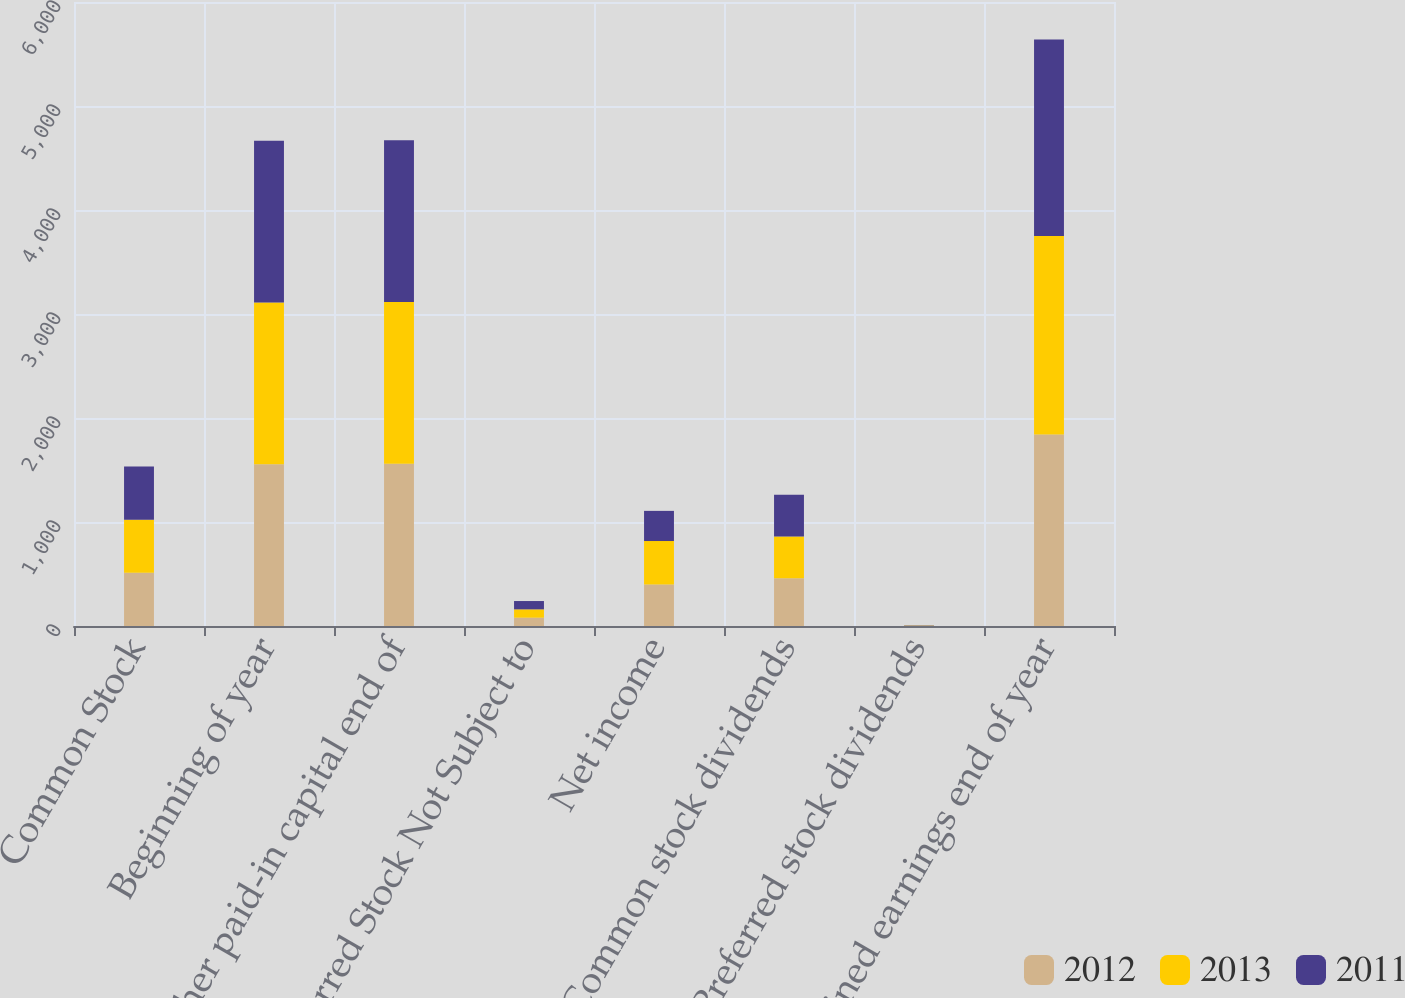Convert chart to OTSL. <chart><loc_0><loc_0><loc_500><loc_500><stacked_bar_chart><ecel><fcel>Common Stock<fcel>Beginning of year<fcel>Other paid-in capital end of<fcel>Preferred Stock Not Subject to<fcel>Net income<fcel>Common stock dividends<fcel>Preferred stock dividends<fcel>Retained earnings end of year<nl><fcel>2012<fcel>511<fcel>1556<fcel>1560<fcel>80<fcel>398<fcel>460<fcel>3<fcel>1842<nl><fcel>2013<fcel>511<fcel>1555<fcel>1556<fcel>80<fcel>419<fcel>400<fcel>3<fcel>1907<nl><fcel>2011<fcel>511<fcel>1555<fcel>1555<fcel>80<fcel>290<fcel>403<fcel>3<fcel>1891<nl></chart> 